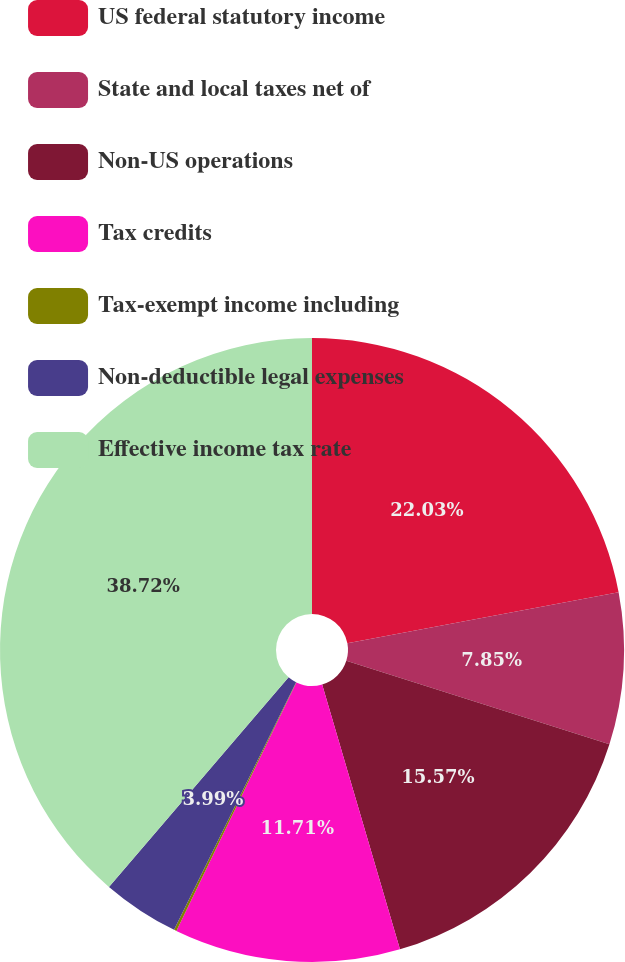<chart> <loc_0><loc_0><loc_500><loc_500><pie_chart><fcel>US federal statutory income<fcel>State and local taxes net of<fcel>Non-US operations<fcel>Tax credits<fcel>Tax-exempt income including<fcel>Non-deductible legal expenses<fcel>Effective income tax rate<nl><fcel>22.04%<fcel>7.85%<fcel>15.57%<fcel>11.71%<fcel>0.13%<fcel>3.99%<fcel>38.73%<nl></chart> 